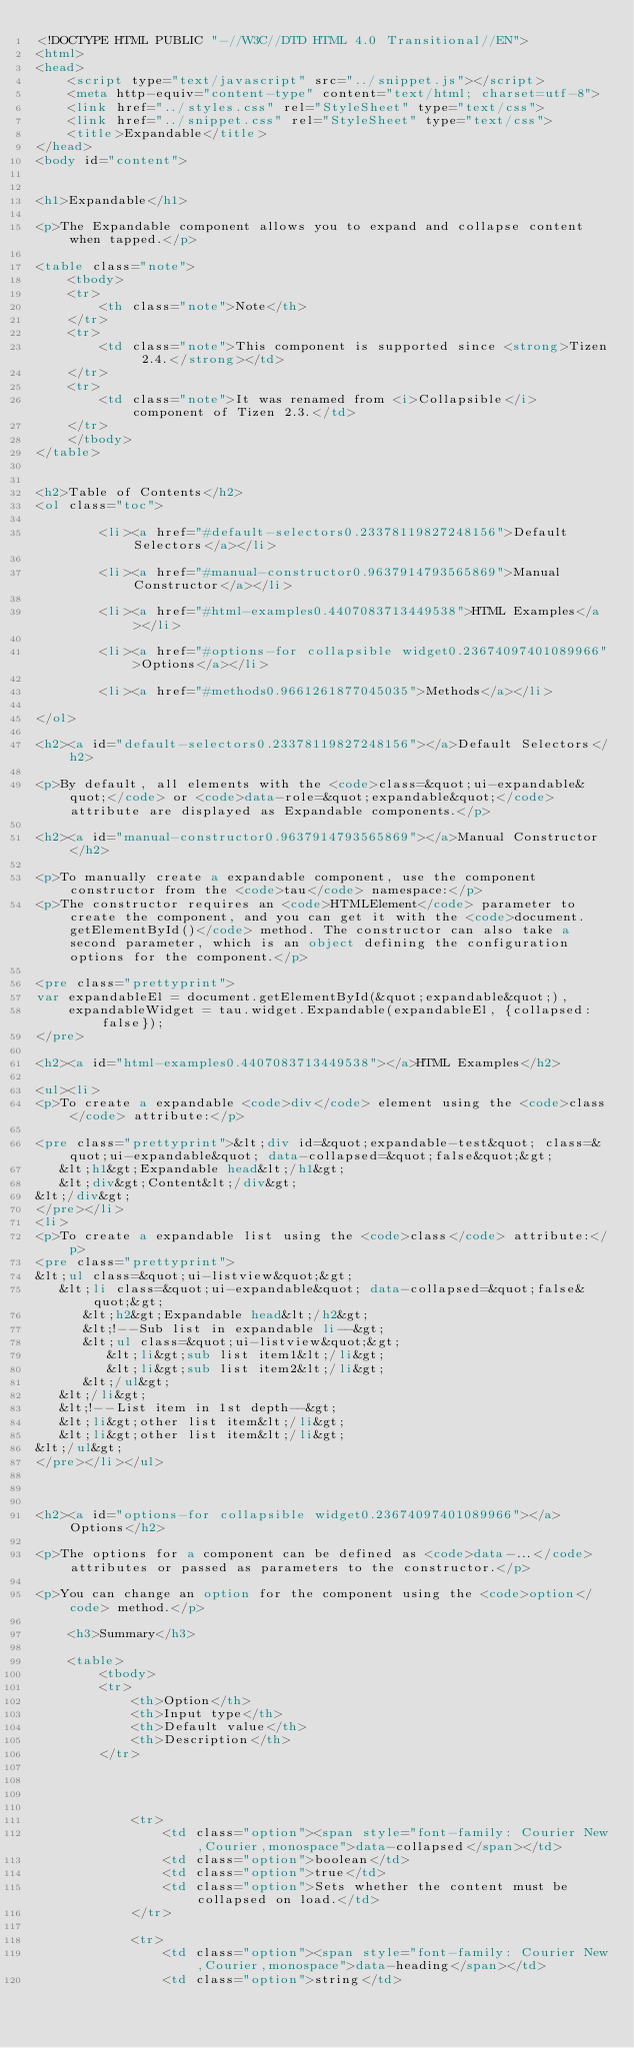Convert code to text. <code><loc_0><loc_0><loc_500><loc_500><_HTML_><!DOCTYPE HTML PUBLIC "-//W3C//DTD HTML 4.0 Transitional//EN">
<html>
<head>
    <script type="text/javascript" src="../snippet.js"></script>
    <meta http-equiv="content-type" content="text/html; charset=utf-8">
    <link href="../styles.css" rel="StyleSheet" type="text/css">
    <link href="../snippet.css" rel="StyleSheet" type="text/css">
    <title>Expandable</title>
</head>
<body id="content">


<h1>Expandable</h1>

<p>The Expandable component allows you to expand and collapse content when tapped.</p>

<table class="note">
    <tbody>
    <tr>
        <th class="note">Note</th>
    </tr>
    <tr>
        <td class="note">This component is supported since <strong>Tizen 2.4.</strong></td>
    </tr>
    <tr>
        <td class="note">It was renamed from <i>Collapsible</i> component of Tizen 2.3.</td>
    </tr>
    </tbody>
</table>


<h2>Table of Contents</h2>
<ol class="toc">

        <li><a href="#default-selectors0.23378119827248156">Default Selectors</a></li>

        <li><a href="#manual-constructor0.9637914793565869">Manual Constructor</a></li>

        <li><a href="#html-examples0.4407083713449538">HTML Examples</a></li>

        <li><a href="#options-for collapsible widget0.23674097401089966">Options</a></li>

        <li><a href="#methods0.9661261877045035">Methods</a></li>

</ol>

<h2><a id="default-selectors0.23378119827248156"></a>Default Selectors</h2>

<p>By default, all elements with the <code>class=&quot;ui-expandable&quot;</code> or <code>data-role=&quot;expandable&quot;</code> attribute are displayed as Expandable components.</p>

<h2><a id="manual-constructor0.9637914793565869"></a>Manual Constructor</h2>

<p>To manually create a expandable component, use the component constructor from the <code>tau</code> namespace:</p>
<p>The constructor requires an <code>HTMLElement</code> parameter to create the component, and you can get it with the <code>document.getElementById()</code> method. The constructor can also take a second parameter, which is an object defining the configuration options for the component.</p>

<pre class="prettyprint">
var expandableEl = document.getElementById(&quot;expandable&quot;),
    expandableWidget = tau.widget.Expandable(expandableEl, {collapsed: false});
</pre>

<h2><a id="html-examples0.4407083713449538"></a>HTML Examples</h2>

<ul><li>
<p>To create a expandable <code>div</code> element using the <code>class</code> attribute:</p>

<pre class="prettyprint">&lt;div id=&quot;expandable-test&quot; class=&quot;ui-expandable&quot; data-collapsed=&quot;false&quot;&gt;
   &lt;h1&gt;Expandable head&lt;/h1&gt;
   &lt;div&gt;Content&lt;/div&gt;
&lt;/div&gt;
</pre></li>
<li>
<p>To create a expandable list using the <code>class</code> attribute:</p>
<pre class="prettyprint">
&lt;ul class=&quot;ui-listview&quot;&gt;
   &lt;li class=&quot;ui-expandable&quot; data-collapsed=&quot;false&quot;&gt;
      &lt;h2&gt;Expandable head&lt;/h2&gt;
      &lt;!--Sub list in expandable li--&gt;
      &lt;ul class=&quot;ui-listview&quot;&gt;
         &lt;li&gt;sub list item1&lt;/li&gt;
         &lt;li&gt;sub list item2&lt;/li&gt;
      &lt;/ul&gt;
   &lt;/li&gt;
   &lt;!--List item in 1st depth--&gt;
   &lt;li&gt;other list item&lt;/li&gt;
   &lt;li&gt;other list item&lt;/li&gt;
&lt;/ul&gt;
</pre></li></ul>



<h2><a id="options-for collapsible widget0.23674097401089966"></a>Options</h2>

<p>The options for a component can be defined as <code>data-...</code> attributes or passed as parameters to the constructor.</p>

<p>You can change an option for the component using the <code>option</code> method.</p>

    <h3>Summary</h3>

    <table>
        <tbody>
        <tr>
            <th>Option</th>
            <th>Input type</th>
            <th>Default value</th>
            <th>Description</th>
        </tr>




            <tr>
                <td class="option"><span style="font-family: Courier New,Courier,monospace">data-collapsed</span></td>
                <td class="option">boolean</td>
                <td class="option">true</td>
                <td class="option">Sets whether the content must be collapsed on load.</td>
            </tr>

            <tr>
                <td class="option"><span style="font-family: Courier New,Courier,monospace">data-heading</span></td>
                <td class="option">string</td></code> 